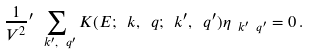<formula> <loc_0><loc_0><loc_500><loc_500>\frac { 1 } { V ^ { 2 } } { ^ { \prime } } \sum _ { \ k ^ { \prime } , \ q ^ { \prime } } K ( E ; \ k , \ q ; \ k ^ { \prime } , \ q ^ { \prime } ) \eta _ { \ k ^ { \prime } \ q ^ { \prime } } = 0 \, .</formula> 